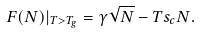Convert formula to latex. <formula><loc_0><loc_0><loc_500><loc_500>F ( N ) | _ { T > T _ { g } } = \gamma \sqrt { N } - T s _ { c } N .</formula> 